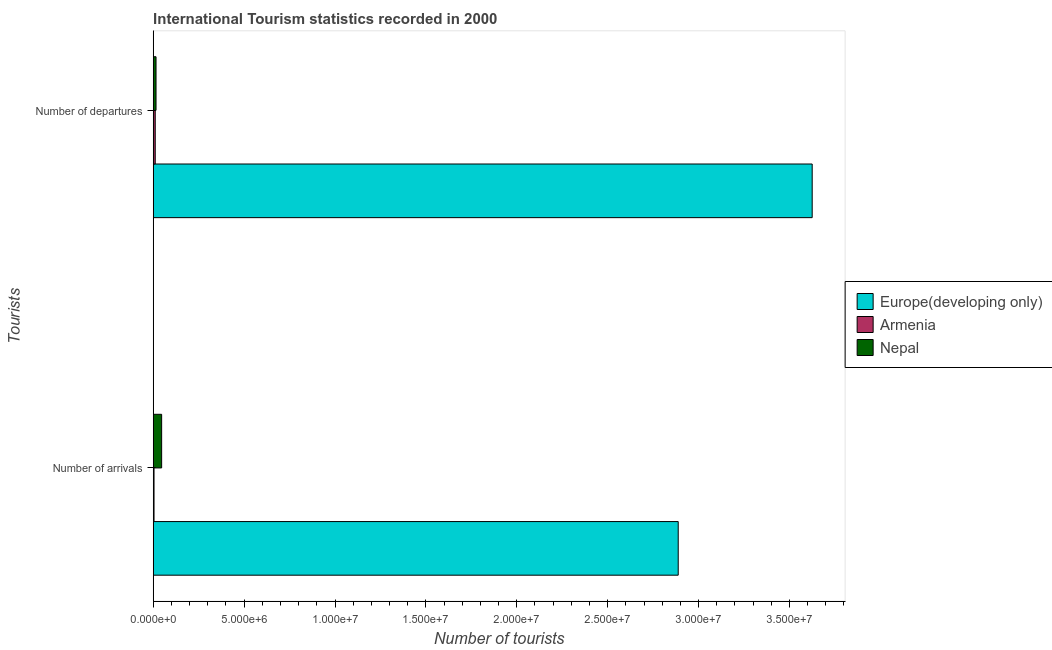How many different coloured bars are there?
Your response must be concise. 3. Are the number of bars per tick equal to the number of legend labels?
Provide a succinct answer. Yes. How many bars are there on the 1st tick from the top?
Your response must be concise. 3. What is the label of the 2nd group of bars from the top?
Give a very brief answer. Number of arrivals. What is the number of tourist arrivals in Europe(developing only)?
Your answer should be compact. 2.89e+07. Across all countries, what is the maximum number of tourist arrivals?
Offer a terse response. 2.89e+07. Across all countries, what is the minimum number of tourist departures?
Keep it short and to the point. 1.11e+05. In which country was the number of tourist arrivals maximum?
Provide a short and direct response. Europe(developing only). In which country was the number of tourist arrivals minimum?
Provide a succinct answer. Armenia. What is the total number of tourist departures in the graph?
Your answer should be very brief. 3.65e+07. What is the difference between the number of tourist arrivals in Nepal and that in Europe(developing only)?
Offer a very short reply. -2.84e+07. What is the difference between the number of tourist departures in Europe(developing only) and the number of tourist arrivals in Armenia?
Provide a short and direct response. 3.62e+07. What is the average number of tourist departures per country?
Offer a terse response. 1.22e+07. What is the difference between the number of tourist arrivals and number of tourist departures in Nepal?
Your answer should be very brief. 3.09e+05. What is the ratio of the number of tourist departures in Armenia to that in Europe(developing only)?
Provide a succinct answer. 0. Is the number of tourist arrivals in Europe(developing only) less than that in Nepal?
Give a very brief answer. No. What does the 1st bar from the top in Number of arrivals represents?
Provide a short and direct response. Nepal. What does the 3rd bar from the bottom in Number of arrivals represents?
Your answer should be very brief. Nepal. Are all the bars in the graph horizontal?
Make the answer very short. Yes. How many countries are there in the graph?
Ensure brevity in your answer.  3. What is the difference between two consecutive major ticks on the X-axis?
Your answer should be very brief. 5.00e+06. Are the values on the major ticks of X-axis written in scientific E-notation?
Provide a succinct answer. Yes. Does the graph contain any zero values?
Your answer should be very brief. No. Does the graph contain grids?
Your answer should be very brief. No. Where does the legend appear in the graph?
Provide a short and direct response. Center right. How many legend labels are there?
Provide a short and direct response. 3. How are the legend labels stacked?
Offer a terse response. Vertical. What is the title of the graph?
Offer a very short reply. International Tourism statistics recorded in 2000. Does "Iceland" appear as one of the legend labels in the graph?
Offer a very short reply. No. What is the label or title of the X-axis?
Make the answer very short. Number of tourists. What is the label or title of the Y-axis?
Your answer should be very brief. Tourists. What is the Number of tourists of Europe(developing only) in Number of arrivals?
Your answer should be compact. 2.89e+07. What is the Number of tourists in Armenia in Number of arrivals?
Your answer should be compact. 4.50e+04. What is the Number of tourists of Nepal in Number of arrivals?
Make the answer very short. 4.64e+05. What is the Number of tourists of Europe(developing only) in Number of departures?
Ensure brevity in your answer.  3.63e+07. What is the Number of tourists of Armenia in Number of departures?
Offer a very short reply. 1.11e+05. What is the Number of tourists in Nepal in Number of departures?
Give a very brief answer. 1.55e+05. Across all Tourists, what is the maximum Number of tourists of Europe(developing only)?
Your answer should be very brief. 3.63e+07. Across all Tourists, what is the maximum Number of tourists in Armenia?
Offer a terse response. 1.11e+05. Across all Tourists, what is the maximum Number of tourists in Nepal?
Keep it short and to the point. 4.64e+05. Across all Tourists, what is the minimum Number of tourists of Europe(developing only)?
Your answer should be compact. 2.89e+07. Across all Tourists, what is the minimum Number of tourists of Armenia?
Offer a very short reply. 4.50e+04. Across all Tourists, what is the minimum Number of tourists of Nepal?
Keep it short and to the point. 1.55e+05. What is the total Number of tourists in Europe(developing only) in the graph?
Keep it short and to the point. 6.51e+07. What is the total Number of tourists in Armenia in the graph?
Ensure brevity in your answer.  1.56e+05. What is the total Number of tourists in Nepal in the graph?
Provide a succinct answer. 6.19e+05. What is the difference between the Number of tourists in Europe(developing only) in Number of arrivals and that in Number of departures?
Provide a short and direct response. -7.37e+06. What is the difference between the Number of tourists of Armenia in Number of arrivals and that in Number of departures?
Your answer should be compact. -6.60e+04. What is the difference between the Number of tourists of Nepal in Number of arrivals and that in Number of departures?
Ensure brevity in your answer.  3.09e+05. What is the difference between the Number of tourists of Europe(developing only) in Number of arrivals and the Number of tourists of Armenia in Number of departures?
Your response must be concise. 2.88e+07. What is the difference between the Number of tourists in Europe(developing only) in Number of arrivals and the Number of tourists in Nepal in Number of departures?
Ensure brevity in your answer.  2.87e+07. What is the difference between the Number of tourists of Armenia in Number of arrivals and the Number of tourists of Nepal in Number of departures?
Give a very brief answer. -1.10e+05. What is the average Number of tourists of Europe(developing only) per Tourists?
Make the answer very short. 3.26e+07. What is the average Number of tourists in Armenia per Tourists?
Keep it short and to the point. 7.80e+04. What is the average Number of tourists in Nepal per Tourists?
Your response must be concise. 3.10e+05. What is the difference between the Number of tourists of Europe(developing only) and Number of tourists of Armenia in Number of arrivals?
Make the answer very short. 2.88e+07. What is the difference between the Number of tourists of Europe(developing only) and Number of tourists of Nepal in Number of arrivals?
Keep it short and to the point. 2.84e+07. What is the difference between the Number of tourists of Armenia and Number of tourists of Nepal in Number of arrivals?
Provide a short and direct response. -4.19e+05. What is the difference between the Number of tourists in Europe(developing only) and Number of tourists in Armenia in Number of departures?
Ensure brevity in your answer.  3.61e+07. What is the difference between the Number of tourists in Europe(developing only) and Number of tourists in Nepal in Number of departures?
Offer a terse response. 3.61e+07. What is the difference between the Number of tourists of Armenia and Number of tourists of Nepal in Number of departures?
Offer a very short reply. -4.40e+04. What is the ratio of the Number of tourists in Europe(developing only) in Number of arrivals to that in Number of departures?
Provide a succinct answer. 0.8. What is the ratio of the Number of tourists of Armenia in Number of arrivals to that in Number of departures?
Ensure brevity in your answer.  0.41. What is the ratio of the Number of tourists in Nepal in Number of arrivals to that in Number of departures?
Keep it short and to the point. 2.99. What is the difference between the highest and the second highest Number of tourists in Europe(developing only)?
Ensure brevity in your answer.  7.37e+06. What is the difference between the highest and the second highest Number of tourists in Armenia?
Offer a terse response. 6.60e+04. What is the difference between the highest and the second highest Number of tourists in Nepal?
Your answer should be compact. 3.09e+05. What is the difference between the highest and the lowest Number of tourists in Europe(developing only)?
Your response must be concise. 7.37e+06. What is the difference between the highest and the lowest Number of tourists of Armenia?
Keep it short and to the point. 6.60e+04. What is the difference between the highest and the lowest Number of tourists in Nepal?
Make the answer very short. 3.09e+05. 